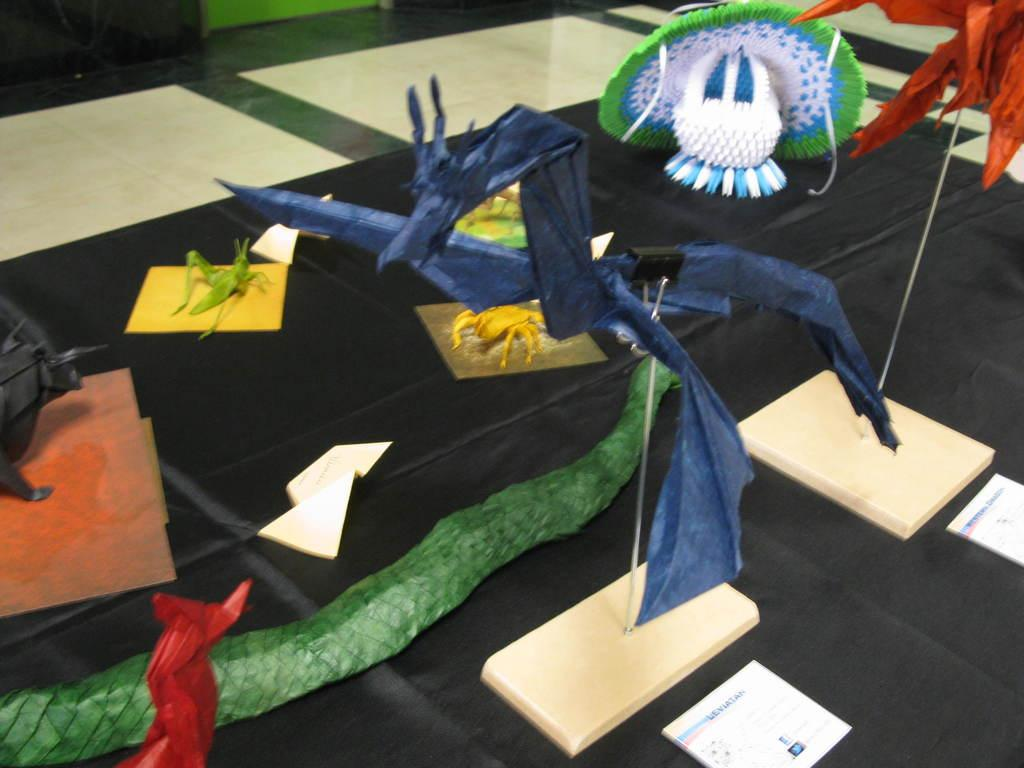What is the color of the surface on which the objects are placed in the image? The surface is black. What can be seen below the objects in the image? There is a floor visible at the bottom of the image. How many jellyfish are swimming on the wall in the image? There are no jellyfish present in the image, and the wall is not visible. 